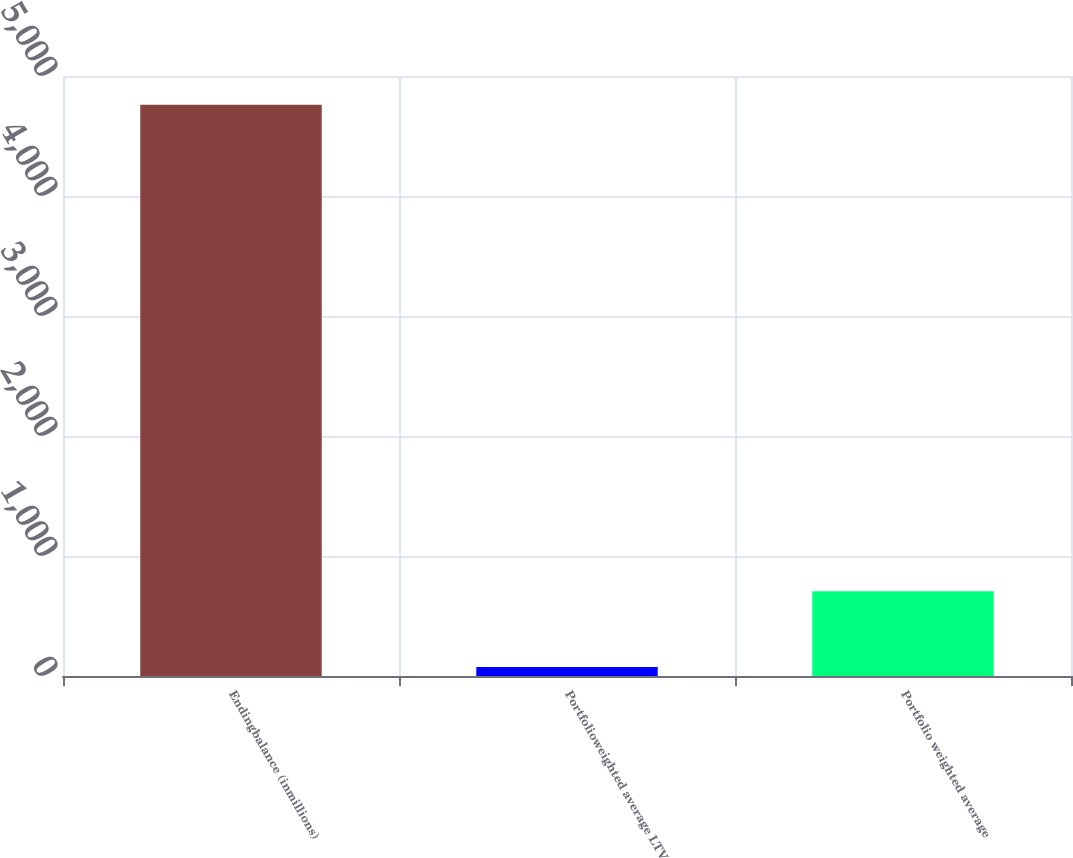Convert chart. <chart><loc_0><loc_0><loc_500><loc_500><bar_chart><fcel>Endingbalance (inmillions)<fcel>Portfolioweighted average LTV<fcel>Portfolio weighted average<nl><fcel>4761<fcel>76<fcel>707<nl></chart> 